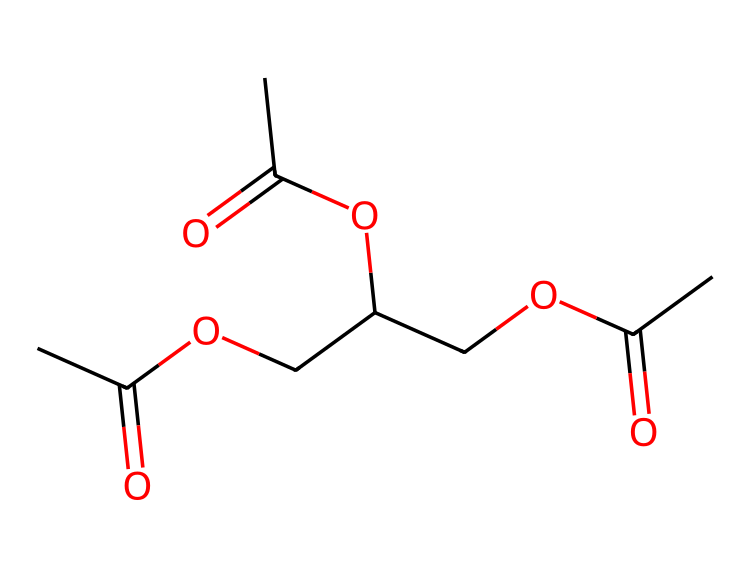What is the molecular formula of triacetin? To determine the molecular formula, count the number of carbon (C), hydrogen (H), and oxygen (O) atoms in the structure. In triacetin's structure, there are 9 carbon atoms, 16 hydrogen atoms, and 6 oxygen atoms. Thus, the molecular formula is C9H16O6.
Answer: C9H16O6 How many ester functional groups are present in triacetin? An ester functional group is characterized by the structure RCOOR'. In the triacetin structure, we can identify three ester groups based on the presence of three segments where carbonyl (C=O) is linked to ether-like groups (alkoxy -O-). Therefore, there are three ester functional groups in triacetin.
Answer: 3 What is the common use of triacetin? Triacetin is primarily known for its role as a food additive and plasticizer, making it useful in food products and various industrial applications.
Answer: food additive What is the total number of oxygen atoms in triacetin? By examining the structure, you can identify each oxygen atom in the functional groups and additional parts of the molecule. There are a total of 6 oxygen atoms clearly visible in the structure of triacetin.
Answer: 6 What type of chemical compound is triacetin classified as? Triacetin is classified as an ester due to the presence of ester functional groups that arise from the reaction of an alcohol and a carboxylic acid.
Answer: ester What is the total number of hydrogen atoms in triacetin? To find the number of hydrogen atoms, count each hydrogen atom attached to carbon in the structure and account for the hydrogens associated with the hydroxyl (if any) and ester groups. In triacetin, there are 16 hydrogen atoms.
Answer: 16 